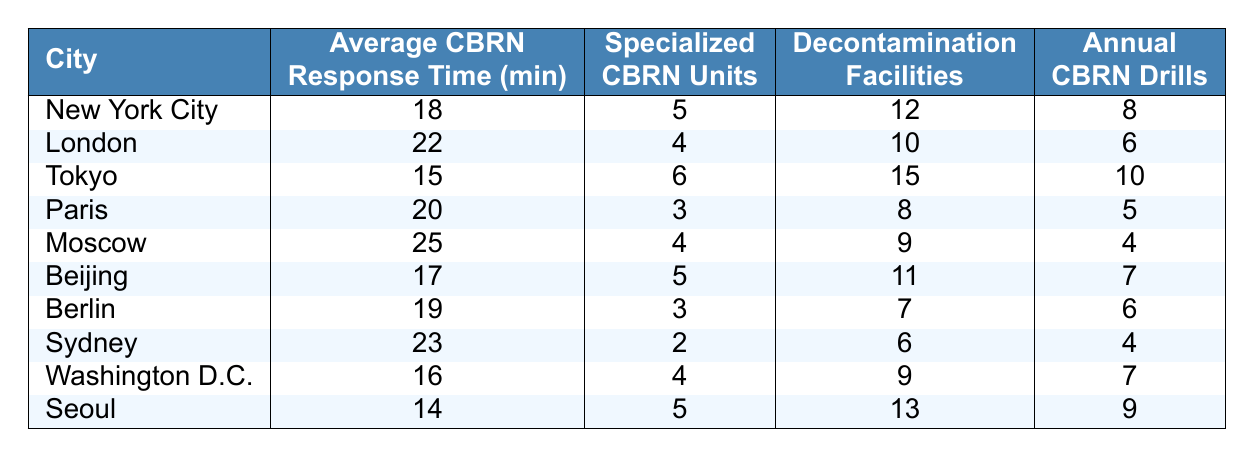What is the average CBRN response time in Tokyo? The table shows that the average CBRN response time in Tokyo is listed directly under the "Average CBRN Response Time (minutes)" column, where it indicates 15 minutes.
Answer: 15 minutes Which city has the highest number of specialized CBRN units? Looking at the "Specialized CBRN Units" column, Tokyo has the highest number listed at 6 units, as no other city exceeds this number.
Answer: Tokyo How many decontamination facilities does London have? The table specifies that London has 10 decontamination facilities, indicated in the "Decontamination Facilities" column.
Answer: 10 What is the total number of annual CBRN drills conducted in New York City and Paris? To find the total, we add the annual CBRN drills from both cities: New York City has 8 drills and Paris has 5 drills. Thus, 8 + 5 = 13 drills.
Answer: 13 Is Seoul's average response time lower than Washington D.C.'s? The table shows that Seoul's response time is 14 minutes and Washington D.C.'s response time is 16 minutes. Since 14 is less than 16, the statement is true.
Answer: Yes What is the average CBRN response time for the cities with 4 specialized CBRN units? The cities with 4 specialized units are London, Moscow, and Washington D.C. Their response times are 22, 25, and 16 minutes respectively. To find the average, we calculate (22 + 25 + 16) / 3 = 21. So the average response time is 21 minutes.
Answer: 21 minutes Which city has the best average CBRN response time? By comparing the "Average CBRN Response Time (minutes)" values from all cities, Tokyo shows the best response time at 15 minutes, which is the lowest among all listed cities.
Answer: Tokyo How many decontamination facilities are there in the city with the worst response time? The worst response time is in Moscow, which is 25 minutes. The table indicates that Moscow has 9 decontamination facilities.
Answer: 9 What is the difference in average CBRN response times between the fastest and slowest cities? The fastest city is Tokyo with 15 minutes and the slowest is Moscow with 25 minutes. The difference is calculated as 25 - 15 = 10 minutes.
Answer: 10 minutes Which city has the fewest annual CBRN drills, and how many drills do they conduct? The city with the fewest annual CBRN drills is Sydney, which conducts only 4 drills as per the "Annual CBRN Drills" column.
Answer: Sydney, 4 drills 